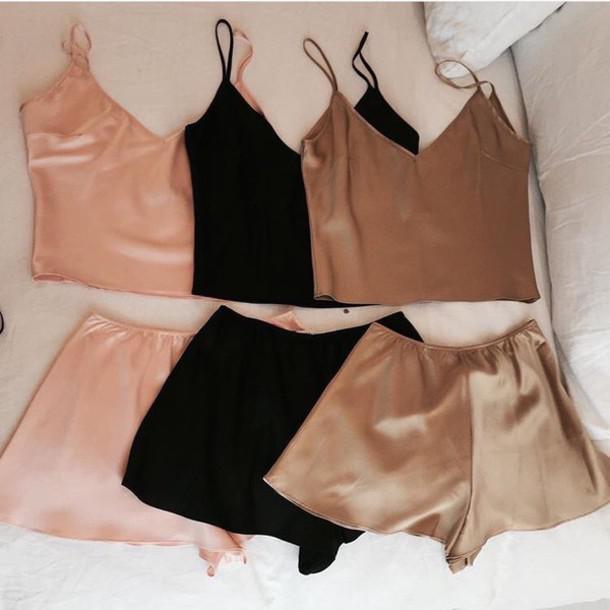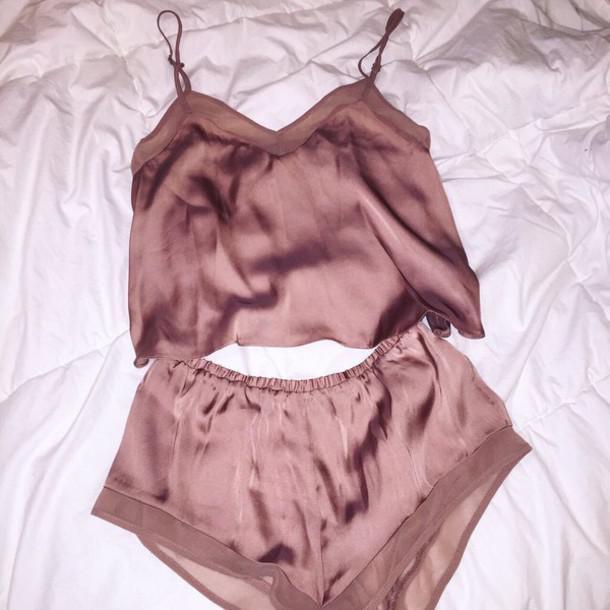The first image is the image on the left, the second image is the image on the right. For the images shown, is this caption "In one image, a woman in lingerie is standing; and in the other image, a woman in lingerie is seated and smiling." true? Answer yes or no. No. The first image is the image on the left, the second image is the image on the right. For the images displayed, is the sentence "The image to the left features an asian woman." factually correct? Answer yes or no. No. 